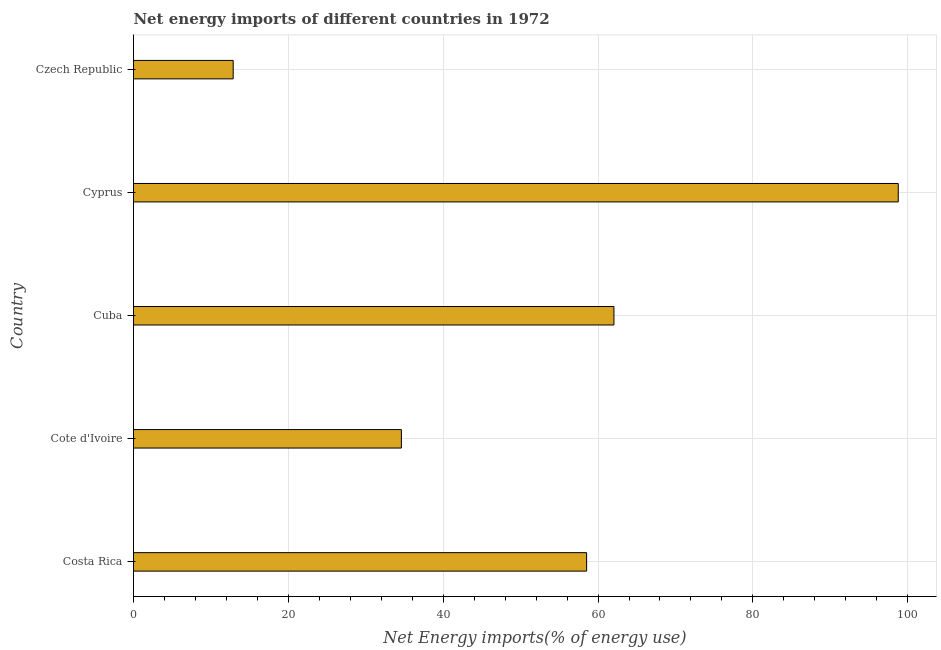Does the graph contain any zero values?
Offer a very short reply. No. What is the title of the graph?
Make the answer very short. Net energy imports of different countries in 1972. What is the label or title of the X-axis?
Offer a terse response. Net Energy imports(% of energy use). What is the energy imports in Cote d'Ivoire?
Your response must be concise. 34.6. Across all countries, what is the maximum energy imports?
Provide a short and direct response. 98.78. Across all countries, what is the minimum energy imports?
Provide a short and direct response. 12.88. In which country was the energy imports maximum?
Your answer should be compact. Cyprus. In which country was the energy imports minimum?
Make the answer very short. Czech Republic. What is the sum of the energy imports?
Offer a very short reply. 266.83. What is the difference between the energy imports in Costa Rica and Czech Republic?
Offer a terse response. 45.65. What is the average energy imports per country?
Provide a short and direct response. 53.37. What is the median energy imports?
Keep it short and to the point. 58.52. In how many countries, is the energy imports greater than 28 %?
Keep it short and to the point. 4. What is the ratio of the energy imports in Costa Rica to that in Cuba?
Your response must be concise. 0.94. Is the energy imports in Cuba less than that in Czech Republic?
Your answer should be compact. No. What is the difference between the highest and the second highest energy imports?
Keep it short and to the point. 36.72. What is the difference between the highest and the lowest energy imports?
Provide a succinct answer. 85.9. In how many countries, is the energy imports greater than the average energy imports taken over all countries?
Ensure brevity in your answer.  3. How many bars are there?
Keep it short and to the point. 5. Are all the bars in the graph horizontal?
Keep it short and to the point. Yes. How many countries are there in the graph?
Offer a terse response. 5. What is the difference between two consecutive major ticks on the X-axis?
Provide a short and direct response. 20. What is the Net Energy imports(% of energy use) of Costa Rica?
Provide a succinct answer. 58.52. What is the Net Energy imports(% of energy use) in Cote d'Ivoire?
Offer a terse response. 34.6. What is the Net Energy imports(% of energy use) of Cuba?
Offer a very short reply. 62.05. What is the Net Energy imports(% of energy use) of Cyprus?
Provide a short and direct response. 98.78. What is the Net Energy imports(% of energy use) of Czech Republic?
Offer a terse response. 12.88. What is the difference between the Net Energy imports(% of energy use) in Costa Rica and Cote d'Ivoire?
Offer a terse response. 23.92. What is the difference between the Net Energy imports(% of energy use) in Costa Rica and Cuba?
Your answer should be compact. -3.53. What is the difference between the Net Energy imports(% of energy use) in Costa Rica and Cyprus?
Provide a succinct answer. -40.25. What is the difference between the Net Energy imports(% of energy use) in Costa Rica and Czech Republic?
Provide a succinct answer. 45.65. What is the difference between the Net Energy imports(% of energy use) in Cote d'Ivoire and Cuba?
Your answer should be compact. -27.45. What is the difference between the Net Energy imports(% of energy use) in Cote d'Ivoire and Cyprus?
Your answer should be compact. -64.18. What is the difference between the Net Energy imports(% of energy use) in Cote d'Ivoire and Czech Republic?
Give a very brief answer. 21.73. What is the difference between the Net Energy imports(% of energy use) in Cuba and Cyprus?
Provide a succinct answer. -36.72. What is the difference between the Net Energy imports(% of energy use) in Cuba and Czech Republic?
Offer a terse response. 49.18. What is the difference between the Net Energy imports(% of energy use) in Cyprus and Czech Republic?
Give a very brief answer. 85.9. What is the ratio of the Net Energy imports(% of energy use) in Costa Rica to that in Cote d'Ivoire?
Your response must be concise. 1.69. What is the ratio of the Net Energy imports(% of energy use) in Costa Rica to that in Cuba?
Your answer should be very brief. 0.94. What is the ratio of the Net Energy imports(% of energy use) in Costa Rica to that in Cyprus?
Provide a succinct answer. 0.59. What is the ratio of the Net Energy imports(% of energy use) in Costa Rica to that in Czech Republic?
Make the answer very short. 4.55. What is the ratio of the Net Energy imports(% of energy use) in Cote d'Ivoire to that in Cuba?
Give a very brief answer. 0.56. What is the ratio of the Net Energy imports(% of energy use) in Cote d'Ivoire to that in Cyprus?
Provide a short and direct response. 0.35. What is the ratio of the Net Energy imports(% of energy use) in Cote d'Ivoire to that in Czech Republic?
Offer a very short reply. 2.69. What is the ratio of the Net Energy imports(% of energy use) in Cuba to that in Cyprus?
Keep it short and to the point. 0.63. What is the ratio of the Net Energy imports(% of energy use) in Cuba to that in Czech Republic?
Provide a succinct answer. 4.82. What is the ratio of the Net Energy imports(% of energy use) in Cyprus to that in Czech Republic?
Your answer should be very brief. 7.67. 